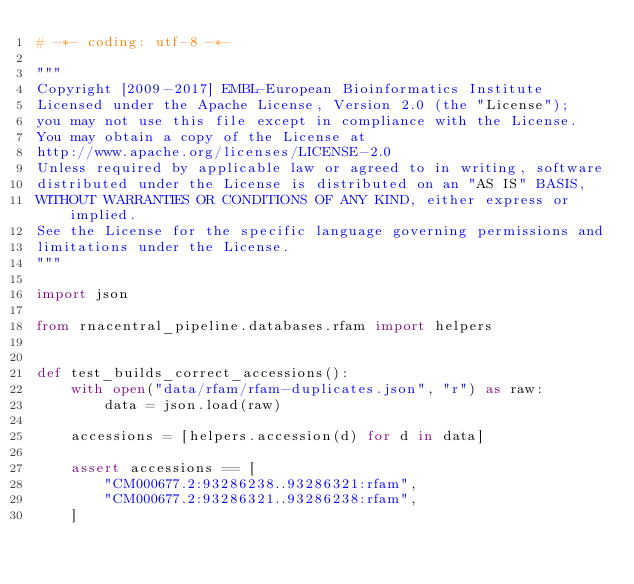<code> <loc_0><loc_0><loc_500><loc_500><_Python_># -*- coding: utf-8 -*-

"""
Copyright [2009-2017] EMBL-European Bioinformatics Institute
Licensed under the Apache License, Version 2.0 (the "License");
you may not use this file except in compliance with the License.
You may obtain a copy of the License at
http://www.apache.org/licenses/LICENSE-2.0
Unless required by applicable law or agreed to in writing, software
distributed under the License is distributed on an "AS IS" BASIS,
WITHOUT WARRANTIES OR CONDITIONS OF ANY KIND, either express or implied.
See the License for the specific language governing permissions and
limitations under the License.
"""

import json

from rnacentral_pipeline.databases.rfam import helpers


def test_builds_correct_accessions():
    with open("data/rfam/rfam-duplicates.json", "r") as raw:
        data = json.load(raw)

    accessions = [helpers.accession(d) for d in data]

    assert accessions == [
        "CM000677.2:93286238..93286321:rfam",
        "CM000677.2:93286321..93286238:rfam",
    ]
</code> 